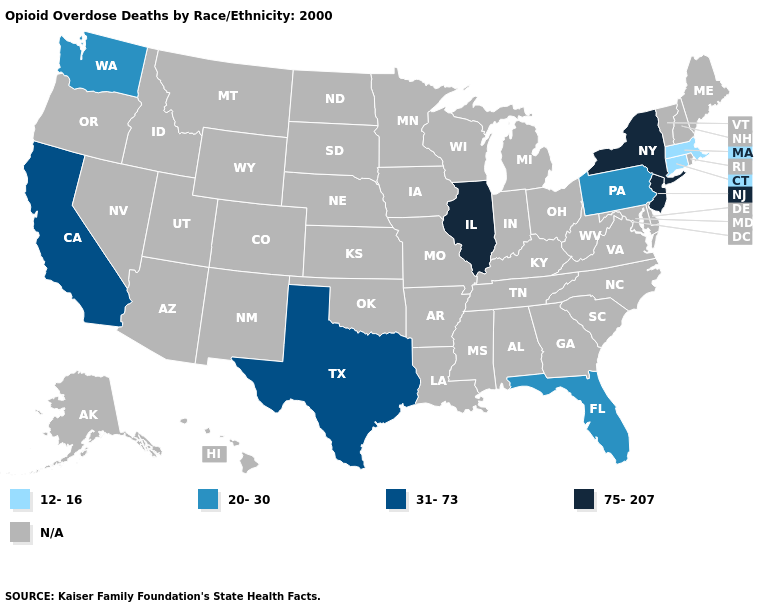Name the states that have a value in the range 75-207?
Write a very short answer. Illinois, New Jersey, New York. Does New Jersey have the lowest value in the USA?
Quick response, please. No. Which states have the highest value in the USA?
Answer briefly. Illinois, New Jersey, New York. Is the legend a continuous bar?
Keep it brief. No. Does Washington have the lowest value in the USA?
Give a very brief answer. No. Name the states that have a value in the range 20-30?
Answer briefly. Florida, Pennsylvania, Washington. Which states hav the highest value in the West?
Concise answer only. California. Does Washington have the lowest value in the West?
Keep it brief. Yes. Does the first symbol in the legend represent the smallest category?
Write a very short answer. Yes. What is the highest value in the West ?
Write a very short answer. 31-73. What is the highest value in states that border Arizona?
Concise answer only. 31-73. Name the states that have a value in the range 20-30?
Concise answer only. Florida, Pennsylvania, Washington. What is the value of Maine?
Write a very short answer. N/A. What is the value of New Mexico?
Give a very brief answer. N/A. Does the map have missing data?
Give a very brief answer. Yes. 